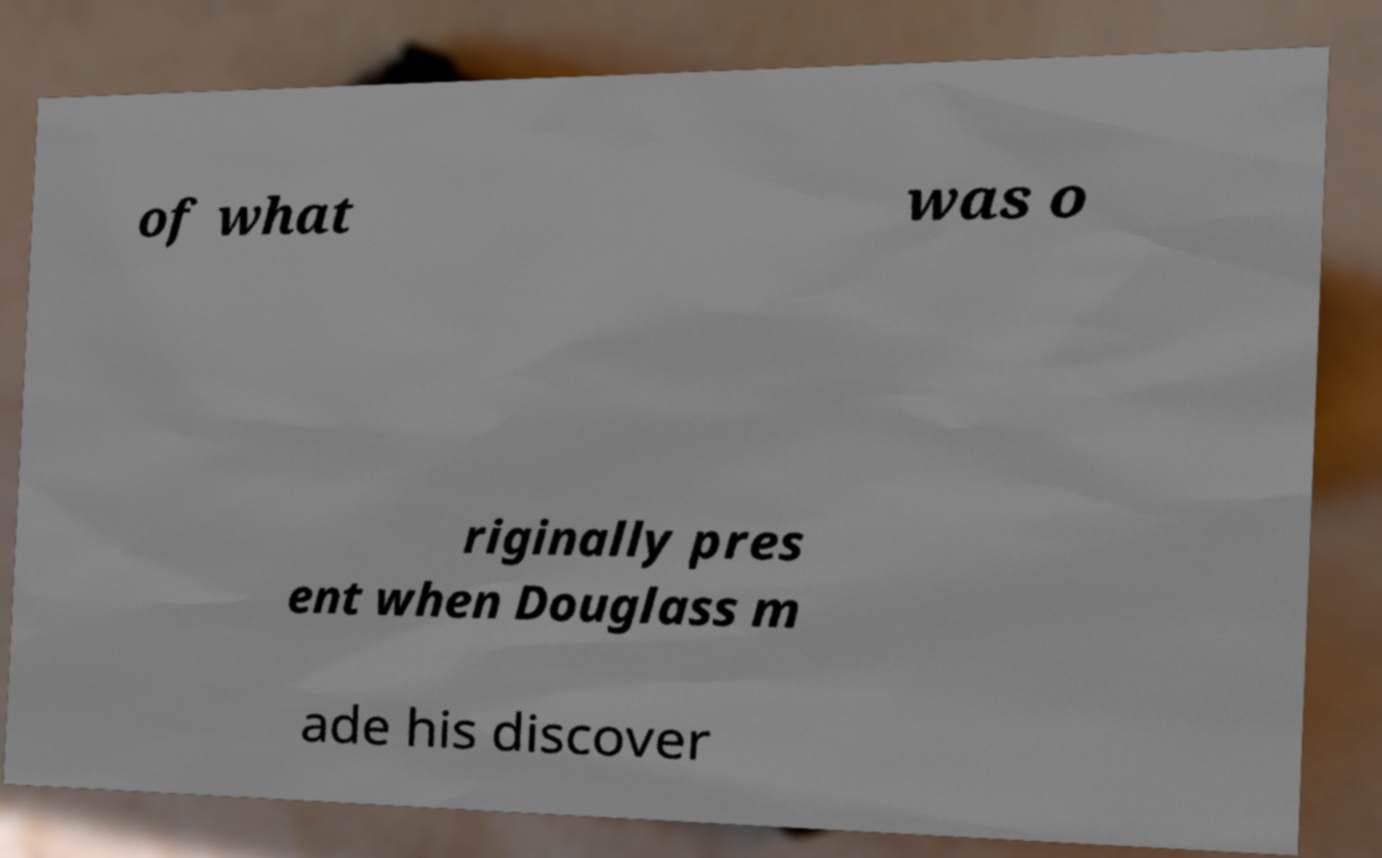Could you extract and type out the text from this image? of what was o riginally pres ent when Douglass m ade his discover 